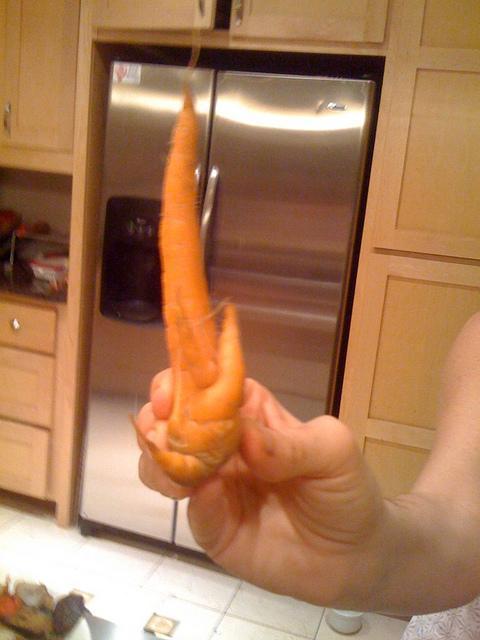How many adult horses are there?
Give a very brief answer. 0. 